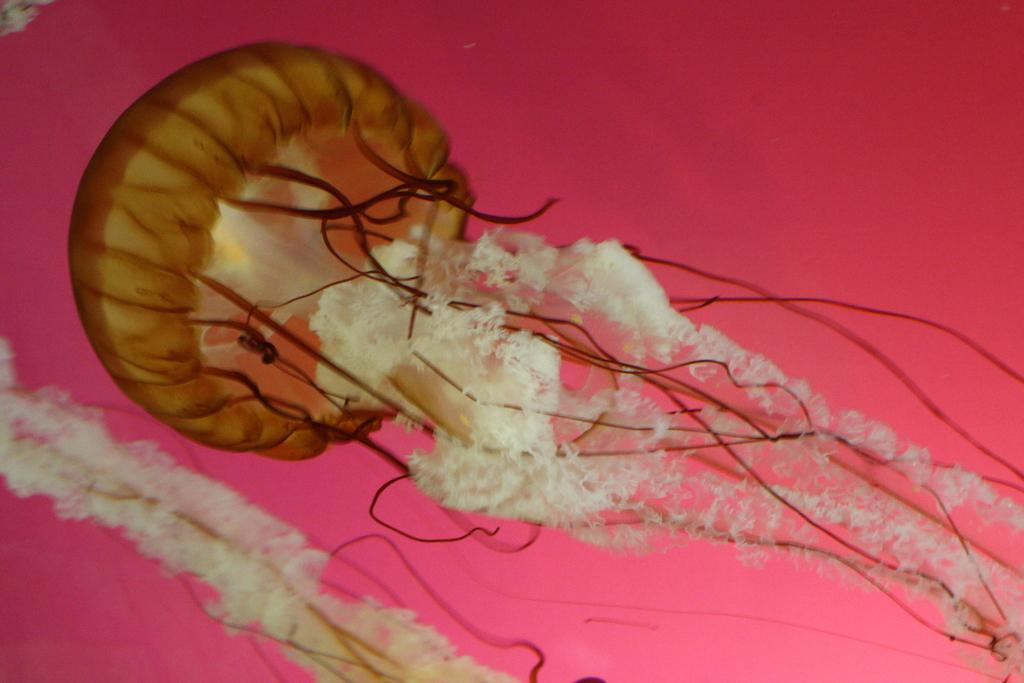What is the main subject of the image? There is a jellyfish in the image. What color is the background of the image? The background of the image is pink. How many cats are visible in the image? There are no cats present in the image; it features a jellyfish against a pink background. What type of eyes does the slave have in the image? There is no slave or any reference to a person in the image; it only contains a jellyfish and a pink background. 